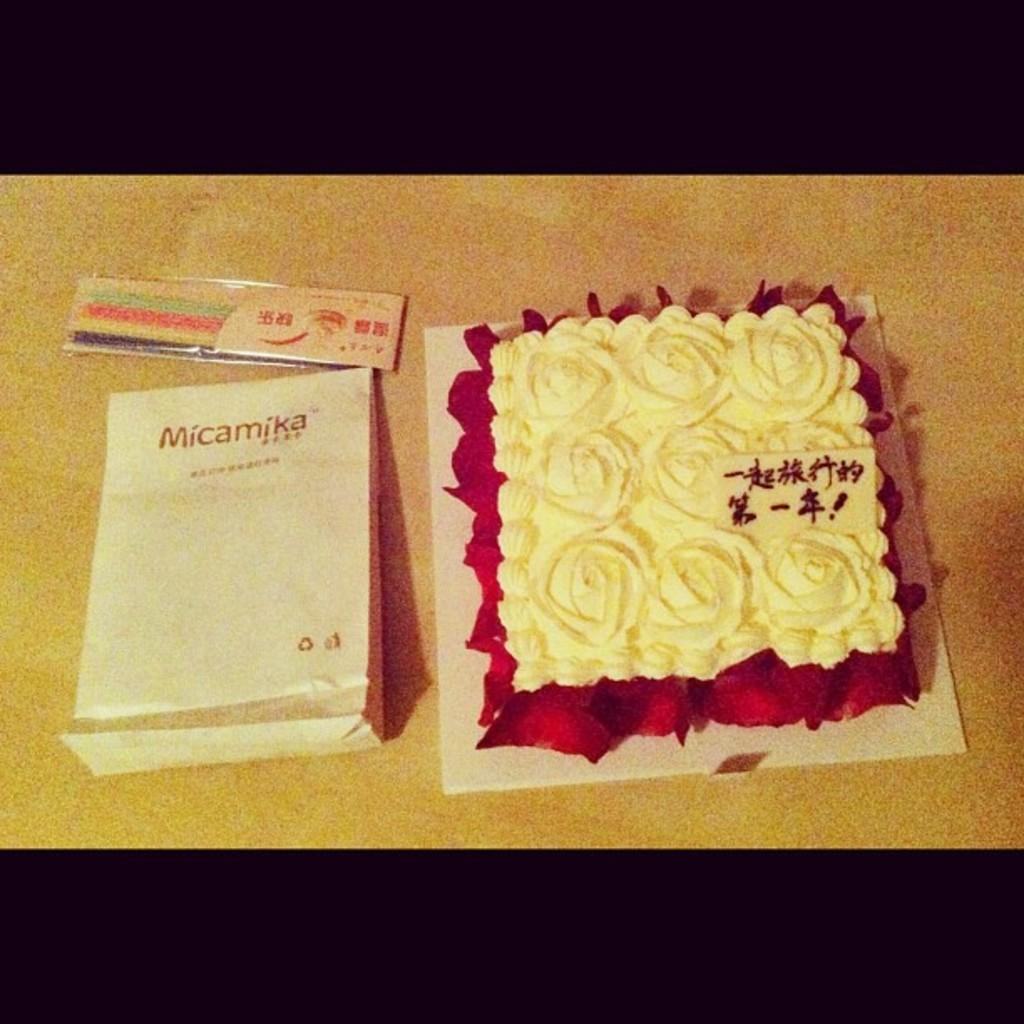What is the main subject of the image? There is a cake in the image. What else can be seen beside the cake? There is a bag beside the cake in the image. How many spiders are crawling on the cake in the image? There are no spiders present in the image; it only features a cake and a bag. 